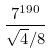Convert formula to latex. <formula><loc_0><loc_0><loc_500><loc_500>\frac { 7 ^ { 1 9 0 } } { \sqrt { 4 } / 8 }</formula> 